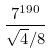Convert formula to latex. <formula><loc_0><loc_0><loc_500><loc_500>\frac { 7 ^ { 1 9 0 } } { \sqrt { 4 } / 8 }</formula> 